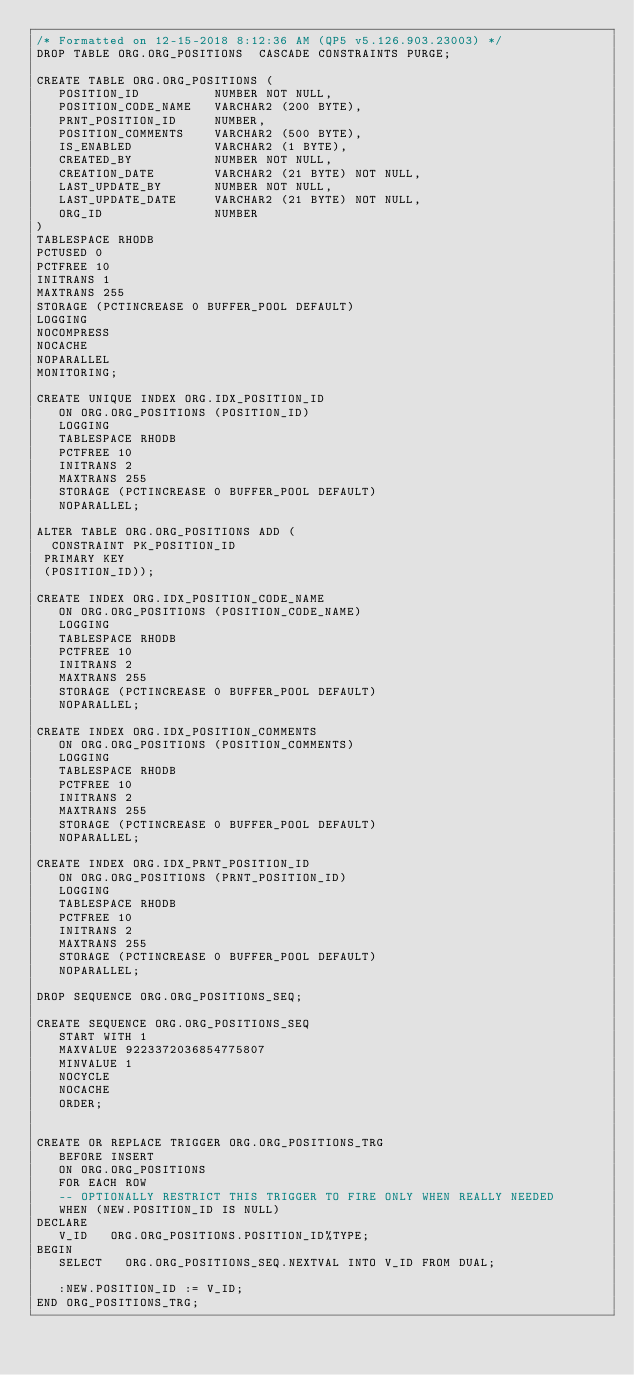<code> <loc_0><loc_0><loc_500><loc_500><_SQL_>/* Formatted on 12-15-2018 8:12:36 AM (QP5 v5.126.903.23003) */
DROP TABLE ORG.ORG_POSITIONS  CASCADE CONSTRAINTS PURGE;

CREATE TABLE ORG.ORG_POSITIONS (
   POSITION_ID          NUMBER NOT NULL,
   POSITION_CODE_NAME   VARCHAR2 (200 BYTE),
   PRNT_POSITION_ID     NUMBER,
   POSITION_COMMENTS    VARCHAR2 (500 BYTE),
   IS_ENABLED           VARCHAR2 (1 BYTE),
   CREATED_BY           NUMBER NOT NULL,
   CREATION_DATE        VARCHAR2 (21 BYTE) NOT NULL,
   LAST_UPDATE_BY       NUMBER NOT NULL,
   LAST_UPDATE_DATE     VARCHAR2 (21 BYTE) NOT NULL,
   ORG_ID               NUMBER
)
TABLESPACE RHODB
PCTUSED 0
PCTFREE 10
INITRANS 1
MAXTRANS 255
STORAGE (PCTINCREASE 0 BUFFER_POOL DEFAULT)
LOGGING
NOCOMPRESS
NOCACHE
NOPARALLEL
MONITORING;

CREATE UNIQUE INDEX ORG.IDX_POSITION_ID
   ON ORG.ORG_POSITIONS (POSITION_ID)
   LOGGING
   TABLESPACE RHODB
   PCTFREE 10
   INITRANS 2
   MAXTRANS 255
   STORAGE (PCTINCREASE 0 BUFFER_POOL DEFAULT)
   NOPARALLEL;

ALTER TABLE ORG.ORG_POSITIONS ADD (
  CONSTRAINT PK_POSITION_ID
 PRIMARY KEY
 (POSITION_ID));

CREATE INDEX ORG.IDX_POSITION_CODE_NAME
   ON ORG.ORG_POSITIONS (POSITION_CODE_NAME)
   LOGGING
   TABLESPACE RHODB
   PCTFREE 10
   INITRANS 2
   MAXTRANS 255
   STORAGE (PCTINCREASE 0 BUFFER_POOL DEFAULT)
   NOPARALLEL;

CREATE INDEX ORG.IDX_POSITION_COMMENTS
   ON ORG.ORG_POSITIONS (POSITION_COMMENTS)
   LOGGING
   TABLESPACE RHODB
   PCTFREE 10
   INITRANS 2
   MAXTRANS 255
   STORAGE (PCTINCREASE 0 BUFFER_POOL DEFAULT)
   NOPARALLEL;

CREATE INDEX ORG.IDX_PRNT_POSITION_ID
   ON ORG.ORG_POSITIONS (PRNT_POSITION_ID)
   LOGGING
   TABLESPACE RHODB
   PCTFREE 10
   INITRANS 2
   MAXTRANS 255
   STORAGE (PCTINCREASE 0 BUFFER_POOL DEFAULT)
   NOPARALLEL;

DROP SEQUENCE ORG.ORG_POSITIONS_SEQ;

CREATE SEQUENCE ORG.ORG_POSITIONS_SEQ
   START WITH 1
   MAXVALUE 9223372036854775807
   MINVALUE 1
   NOCYCLE
   NOCACHE
   ORDER;


CREATE OR REPLACE TRIGGER ORG.ORG_POSITIONS_TRG
   BEFORE INSERT
   ON ORG.ORG_POSITIONS
   FOR EACH ROW
   -- OPTIONALLY RESTRICT THIS TRIGGER TO FIRE ONLY WHEN REALLY NEEDED
   WHEN (NEW.POSITION_ID IS NULL)
DECLARE
   V_ID   ORG.ORG_POSITIONS.POSITION_ID%TYPE;
BEGIN
   SELECT   ORG.ORG_POSITIONS_SEQ.NEXTVAL INTO V_ID FROM DUAL;

   :NEW.POSITION_ID := V_ID;
END ORG_POSITIONS_TRG;</code> 